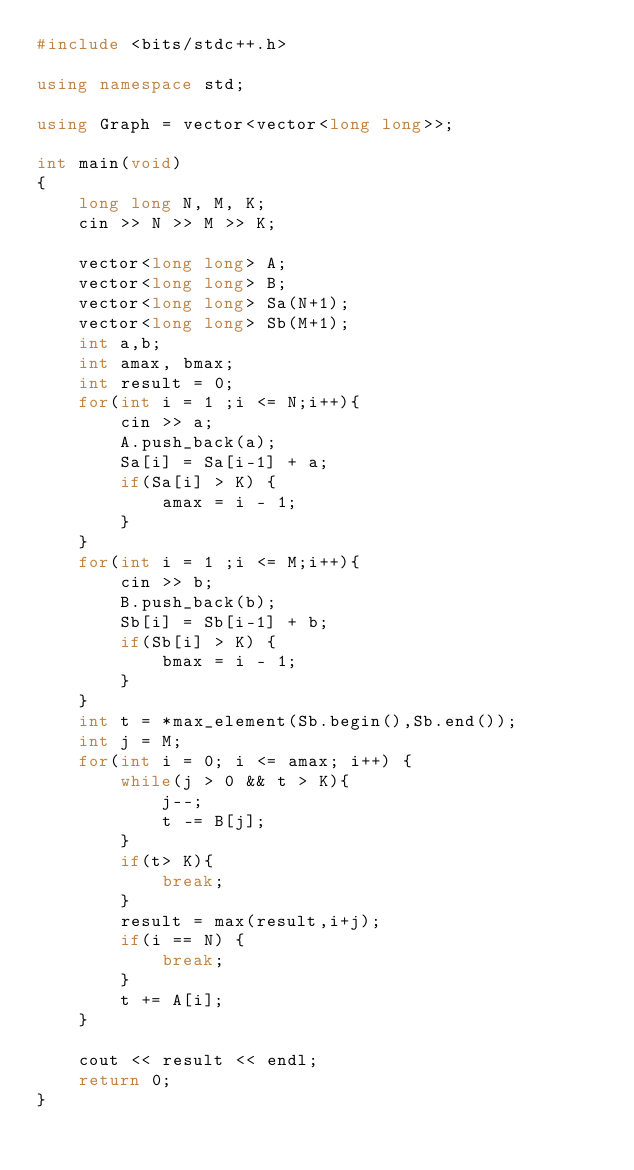<code> <loc_0><loc_0><loc_500><loc_500><_C++_>#include <bits/stdc++.h>

using namespace std;

using Graph = vector<vector<long long>>;

int main(void)
{
    long long N, M, K;
    cin >> N >> M >> K;

    vector<long long> A;
    vector<long long> B;
    vector<long long> Sa(N+1);
    vector<long long> Sb(M+1);
    int a,b;
    int amax, bmax;
    int result = 0;
    for(int i = 1 ;i <= N;i++){
        cin >> a;
        A.push_back(a);
        Sa[i] = Sa[i-1] + a;
        if(Sa[i] > K) {
            amax = i - 1;
        }
    }
    for(int i = 1 ;i <= M;i++){
        cin >> b;
        B.push_back(b);
        Sb[i] = Sb[i-1] + b;
        if(Sb[i] > K) {
            bmax = i - 1;
        }
    }
    int t = *max_element(Sb.begin(),Sb.end());
    int j = M;
    for(int i = 0; i <= amax; i++) {
        while(j > 0 && t > K){
            j--;
            t -= B[j];
        }
        if(t> K){
            break;
        }
        result = max(result,i+j);
        if(i == N) {
            break;
        }
        t += A[i];
    }
        
    cout << result << endl;
    return 0;
}</code> 